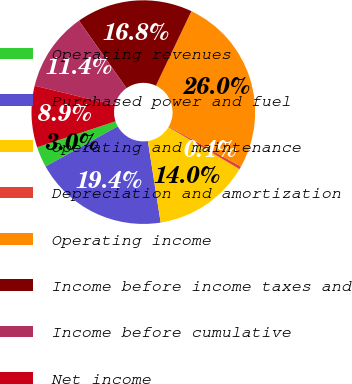<chart> <loc_0><loc_0><loc_500><loc_500><pie_chart><fcel>Operating revenues<fcel>Purchased power and fuel<fcel>Operating and maintenance<fcel>Depreciation and amortization<fcel>Operating income<fcel>Income before income taxes and<fcel>Income before cumulative<fcel>Net income<nl><fcel>2.99%<fcel>19.4%<fcel>14.0%<fcel>0.43%<fcel>26.01%<fcel>16.84%<fcel>11.44%<fcel>8.89%<nl></chart> 